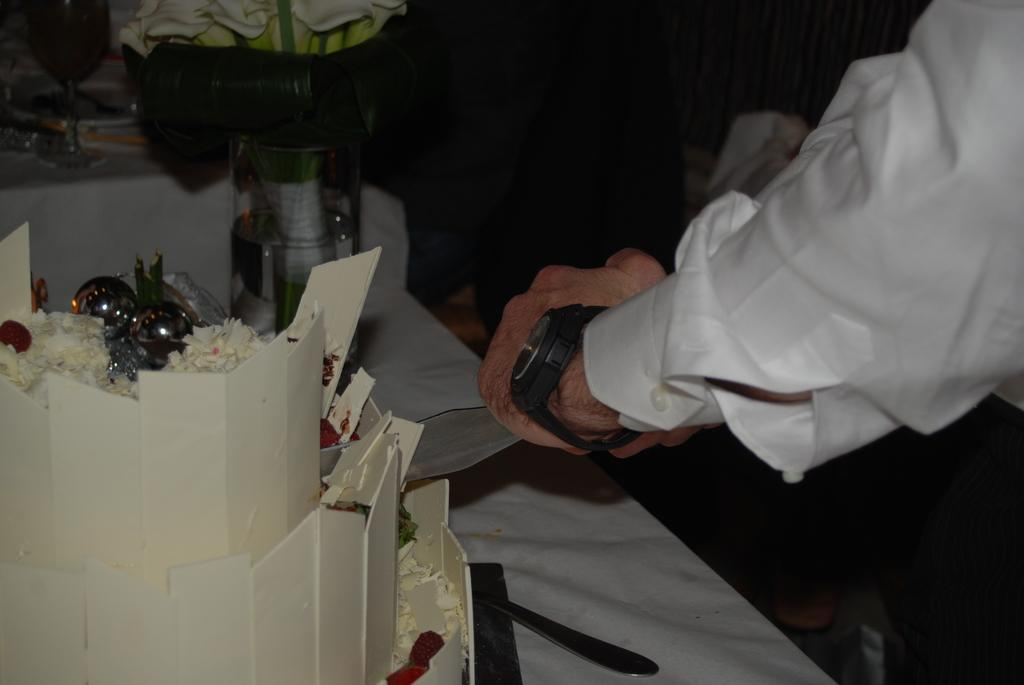What part of a person can be seen in the image? There is a hand of a person in the image. What is the main object on the table in the image? There is a cake on the table. Are there any other objects on the table besides the cake? Yes, there are other objects on the table. What type of brass instrument is being played in the image? There is no brass instrument present in the image; it only features a hand, a table, a cake, and other unspecified objects. 